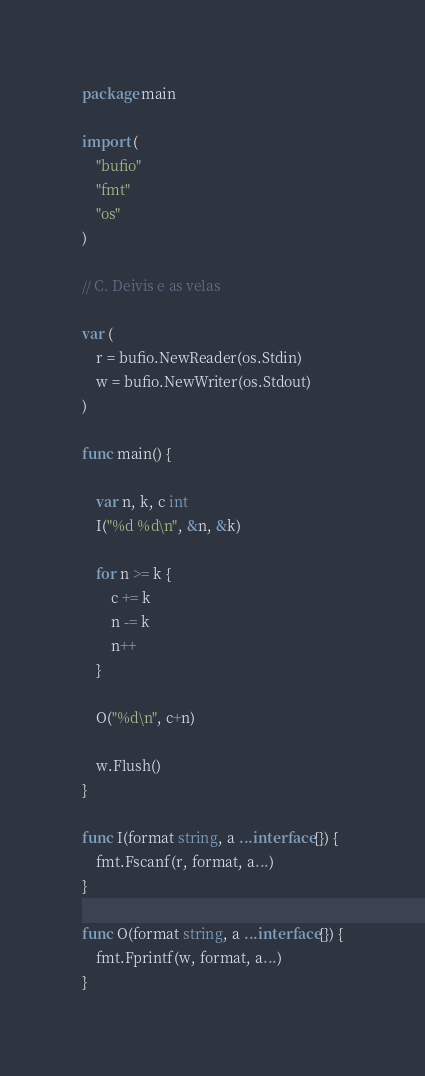Convert code to text. <code><loc_0><loc_0><loc_500><loc_500><_Go_>package main

import (
	"bufio"
	"fmt"
	"os"
)

// C. Deivis e as velas

var (
	r = bufio.NewReader(os.Stdin)
	w = bufio.NewWriter(os.Stdout)
)

func main() {

	var n, k, c int
	I("%d %d\n", &n, &k)

	for n >= k {
		c += k
		n -= k
		n++
	}

	O("%d\n", c+n)

	w.Flush()
}

func I(format string, a ...interface{}) {
	fmt.Fscanf(r, format, a...)
}

func O(format string, a ...interface{}) {
	fmt.Fprintf(w, format, a...)
}
</code> 